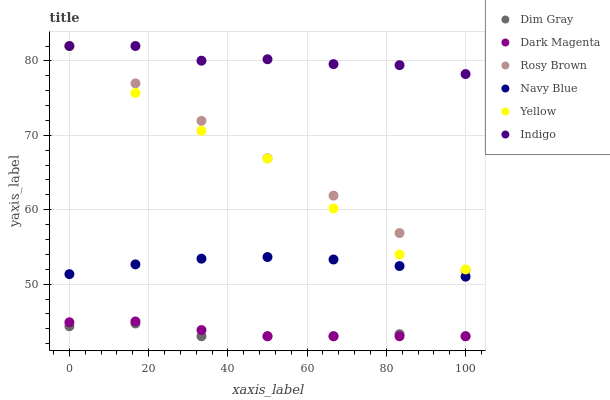Does Dim Gray have the minimum area under the curve?
Answer yes or no. Yes. Does Indigo have the maximum area under the curve?
Answer yes or no. Yes. Does Dark Magenta have the minimum area under the curve?
Answer yes or no. No. Does Dark Magenta have the maximum area under the curve?
Answer yes or no. No. Is Rosy Brown the smoothest?
Answer yes or no. Yes. Is Yellow the roughest?
Answer yes or no. Yes. Is Indigo the smoothest?
Answer yes or no. No. Is Indigo the roughest?
Answer yes or no. No. Does Dim Gray have the lowest value?
Answer yes or no. Yes. Does Indigo have the lowest value?
Answer yes or no. No. Does Yellow have the highest value?
Answer yes or no. Yes. Does Dark Magenta have the highest value?
Answer yes or no. No. Is Navy Blue less than Rosy Brown?
Answer yes or no. Yes. Is Yellow greater than Dark Magenta?
Answer yes or no. Yes. Does Rosy Brown intersect Yellow?
Answer yes or no. Yes. Is Rosy Brown less than Yellow?
Answer yes or no. No. Is Rosy Brown greater than Yellow?
Answer yes or no. No. Does Navy Blue intersect Rosy Brown?
Answer yes or no. No. 